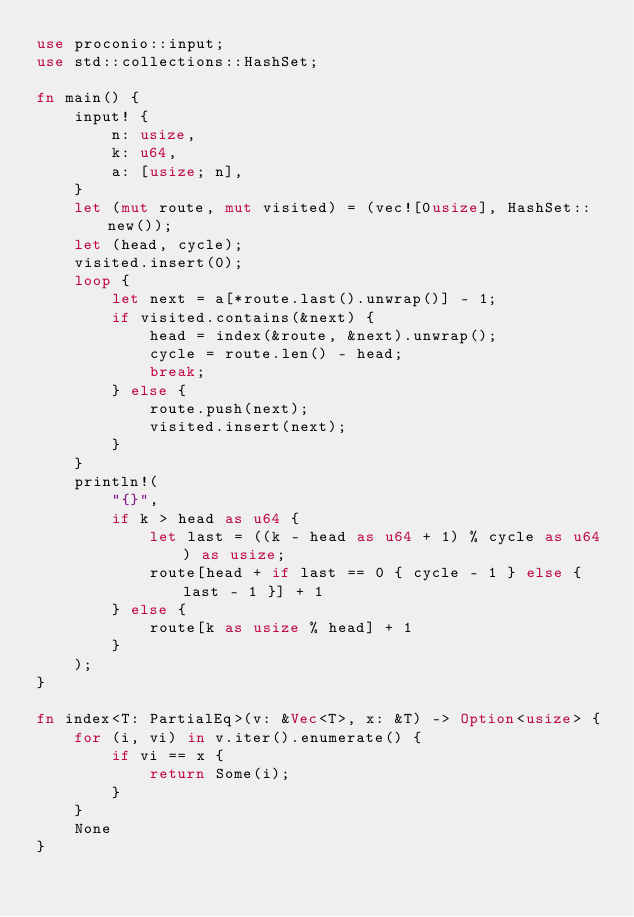Convert code to text. <code><loc_0><loc_0><loc_500><loc_500><_Rust_>use proconio::input;
use std::collections::HashSet;

fn main() {
    input! {
        n: usize,
        k: u64,
        a: [usize; n],
    }
    let (mut route, mut visited) = (vec![0usize], HashSet::new());
    let (head, cycle);
    visited.insert(0);
    loop {
        let next = a[*route.last().unwrap()] - 1;
        if visited.contains(&next) {
            head = index(&route, &next).unwrap();
            cycle = route.len() - head;
            break;
        } else {
            route.push(next);
            visited.insert(next);
        }
    }
    println!(
        "{}",
        if k > head as u64 {
            let last = ((k - head as u64 + 1) % cycle as u64) as usize;
            route[head + if last == 0 { cycle - 1 } else { last - 1 }] + 1
        } else {
            route[k as usize % head] + 1
        }
    );
}

fn index<T: PartialEq>(v: &Vec<T>, x: &T) -> Option<usize> {
    for (i, vi) in v.iter().enumerate() {
        if vi == x {
            return Some(i);
        }
    }
    None
}
</code> 